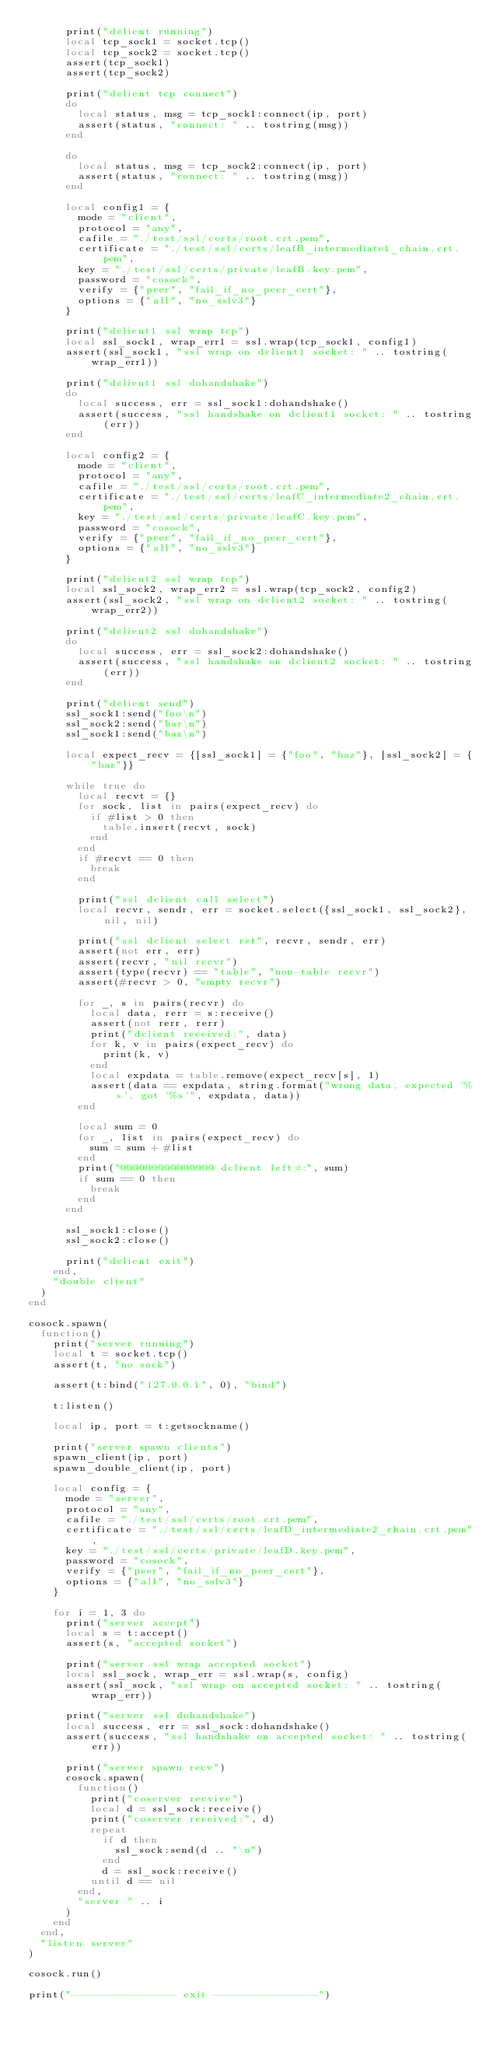<code> <loc_0><loc_0><loc_500><loc_500><_Lua_>      print("dclient running")
      local tcp_sock1 = socket.tcp()
      local tcp_sock2 = socket.tcp()
      assert(tcp_sock1)
      assert(tcp_sock2)

      print("dclient tcp connect")
      do
        local status, msg = tcp_sock1:connect(ip, port)
        assert(status, "connect: " .. tostring(msg))
      end

      do
        local status, msg = tcp_sock2:connect(ip, port)
        assert(status, "connect: " .. tostring(msg))
      end

      local config1 = {
        mode = "client",
        protocol = "any",
        cafile = "./test/ssl/certs/root.crt.pem",
        certificate = "./test/ssl/certs/leafB_intermediate1_chain.crt.pem",
        key = "./test/ssl/certs/private/leafB.key.pem",
        password = "cosock",
        verify = {"peer", "fail_if_no_peer_cert"},
        options = {"all", "no_sslv3"}
      }

      print("dclient1 ssl wrap tcp")
      local ssl_sock1, wrap_err1 = ssl.wrap(tcp_sock1, config1)
      assert(ssl_sock1, "ssl wrap on dclient1 socket: " .. tostring(wrap_err1))

      print("dclient1 ssl dohandshake")
      do
        local success, err = ssl_sock1:dohandshake()
        assert(success, "ssl handshake on dclient1 socket: " .. tostring(err))
      end

      local config2 = {
        mode = "client",
        protocol = "any",
        cafile = "./test/ssl/certs/root.crt.pem",
        certificate = "./test/ssl/certs/leafC_intermediate2_chain.crt.pem",
        key = "./test/ssl/certs/private/leafC.key.pem",
        password = "cosock",
        verify = {"peer", "fail_if_no_peer_cert"},
        options = {"all", "no_sslv3"}
      }

      print("dclient2 ssl wrap tcp")
      local ssl_sock2, wrap_err2 = ssl.wrap(tcp_sock2, config2)
      assert(ssl_sock2, "ssl wrap on dclient2 socket: " .. tostring(wrap_err2))

      print("dclient2 ssl dohandshake")
      do
        local success, err = ssl_sock2:dohandshake()
        assert(success, "ssl handshake on dclient2 socket: " .. tostring(err))
      end

      print("dclient send")
      ssl_sock1:send("foo\n")
      ssl_sock2:send("bar\n")
      ssl_sock1:send("baz\n")

      local expect_recv = {[ssl_sock1] = {"foo", "baz"}, [ssl_sock2] = {"bar"}}

      while true do
        local recvt = {}
        for sock, list in pairs(expect_recv) do
          if #list > 0 then
            table.insert(recvt, sock)
          end
        end
        if #recvt == 0 then
          break
        end

        print("ssl dclient call select")
        local recvr, sendr, err = socket.select({ssl_sock1, ssl_sock2}, nil, nil)

        print("ssl dclient select ret", recvr, sendr, err)
        assert(not err, err)
        assert(recvr, "nil recvr")
        assert(type(recvr) == "table", "non-table recvr")
        assert(#recvr > 0, "empty recvr")

        for _, s in pairs(recvr) do
          local data, rerr = s:receive()
          assert(not rerr, rerr)
          print("dclient received:", data)
          for k, v in pairs(expect_recv) do
            print(k, v)
          end
          local expdata = table.remove(expect_recv[s], 1)
          assert(data == expdata, string.format("wrong data, expected '%s', got '%s'", expdata, data))
        end

        local sum = 0
        for _, list in pairs(expect_recv) do
          sum = sum + #list
        end
        print("@@@@@@@@@@@@@@@ dclient left#:", sum)
        if sum == 0 then
          break
        end
      end

      ssl_sock1:close()
      ssl_sock2:close()

      print("dclient exit")
    end,
    "double client"
  )
end

cosock.spawn(
  function()
    print("server running")
    local t = socket.tcp()
    assert(t, "no sock")

    assert(t:bind("127.0.0.1", 0), "bind")

    t:listen()

    local ip, port = t:getsockname()

    print("server spawn clients")
    spawn_client(ip, port)
    spawn_double_client(ip, port)

    local config = {
      mode = "server",
      protocol = "any",
      cafile = "./test/ssl/certs/root.crt.pem",
      certificate = "./test/ssl/certs/leafD_intermediate2_chain.crt.pem",
      key = "./test/ssl/certs/private/leafD.key.pem",
      password = "cosock",
      verify = {"peer", "fail_if_no_peer_cert"},
      options = {"all", "no_sslv3"}
    }

    for i = 1, 3 do
      print("server accept")
      local s = t:accept()
      assert(s, "accepted socket")

      print("server ssl wrap accepted socket")
      local ssl_sock, wrap_err = ssl.wrap(s, config)
      assert(ssl_sock, "ssl wrap on accepted socket: " .. tostring(wrap_err))

      print("server ssl dohandshake")
      local success, err = ssl_sock:dohandshake()
      assert(success, "ssl handshake on accepted socket: " .. tostring(err))

      print("server spawn recv")
      cosock.spawn(
        function()
          print("coserver recvive")
          local d = ssl_sock:receive()
          print("coserver received:", d)
          repeat
            if d then
              ssl_sock:send(d .. "\n")
            end
            d = ssl_sock:receive()
          until d == nil
        end,
        "server " .. i
      )
    end
  end,
  "listen server"
)

cosock.run()

print("----------------- exit -----------------")
</code> 